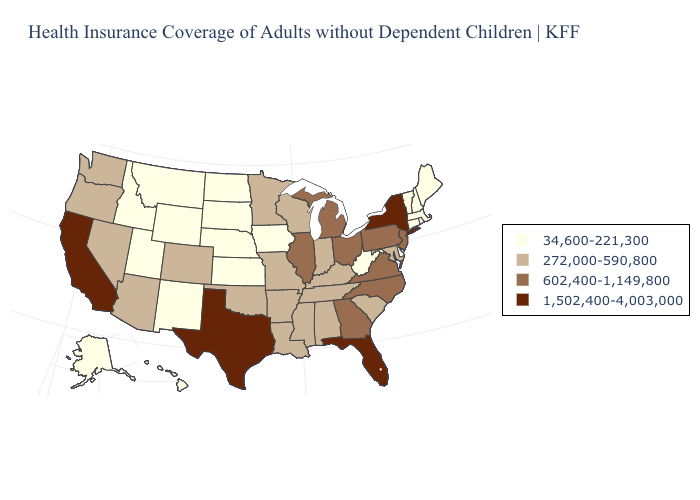Among the states that border West Virginia , does Kentucky have the lowest value?
Give a very brief answer. Yes. Name the states that have a value in the range 272,000-590,800?
Concise answer only. Alabama, Arizona, Arkansas, Colorado, Indiana, Kentucky, Louisiana, Maryland, Minnesota, Mississippi, Missouri, Nevada, Oklahoma, Oregon, South Carolina, Tennessee, Washington, Wisconsin. Does Minnesota have the same value as Virginia?
Give a very brief answer. No. Name the states that have a value in the range 1,502,400-4,003,000?
Keep it brief. California, Florida, New York, Texas. How many symbols are there in the legend?
Short answer required. 4. Among the states that border New Mexico , which have the lowest value?
Quick response, please. Utah. Name the states that have a value in the range 1,502,400-4,003,000?
Keep it brief. California, Florida, New York, Texas. Does Alabama have a higher value than Iowa?
Give a very brief answer. Yes. Which states have the highest value in the USA?
Write a very short answer. California, Florida, New York, Texas. What is the lowest value in the USA?
Short answer required. 34,600-221,300. Does California have the highest value in the USA?
Answer briefly. Yes. Name the states that have a value in the range 272,000-590,800?
Write a very short answer. Alabama, Arizona, Arkansas, Colorado, Indiana, Kentucky, Louisiana, Maryland, Minnesota, Mississippi, Missouri, Nevada, Oklahoma, Oregon, South Carolina, Tennessee, Washington, Wisconsin. Among the states that border Minnesota , does North Dakota have the highest value?
Answer briefly. No. What is the lowest value in the USA?
Give a very brief answer. 34,600-221,300. Does the first symbol in the legend represent the smallest category?
Write a very short answer. Yes. 